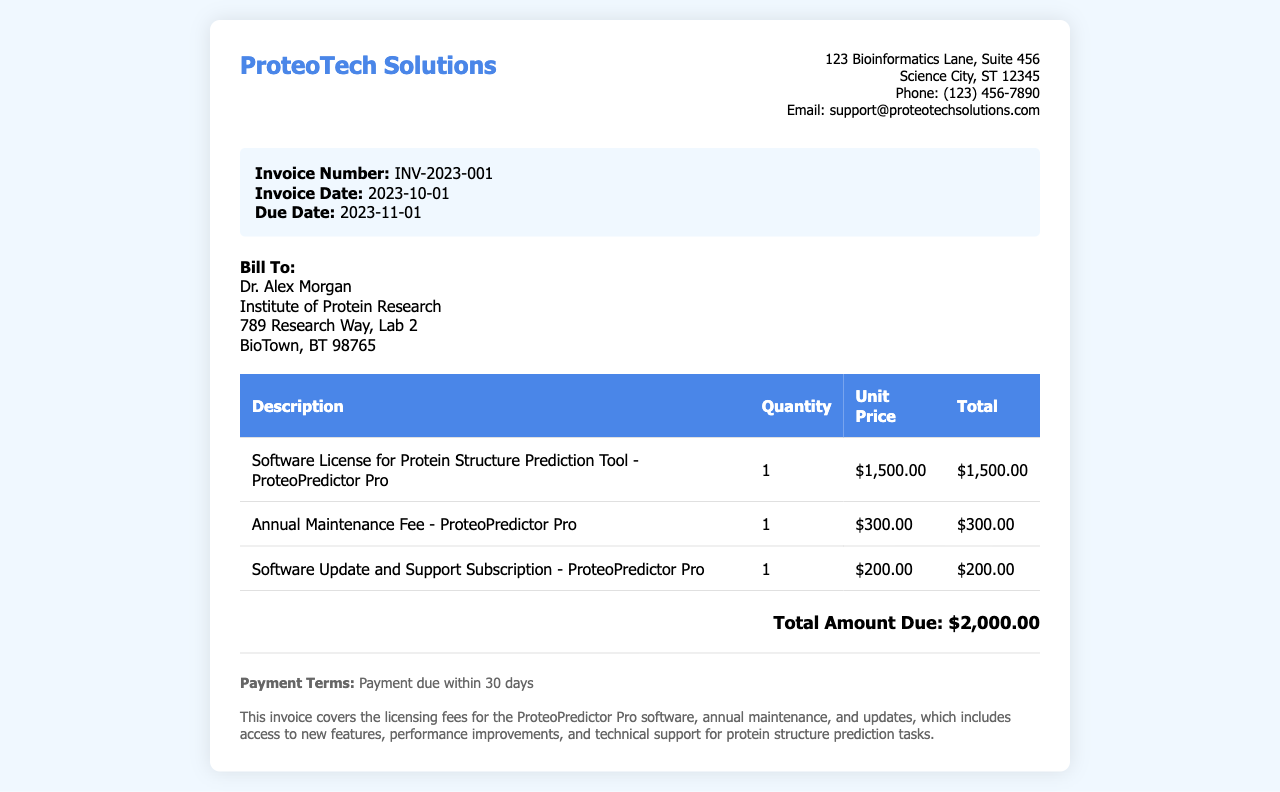What is the invoice number? The invoice number is stated in the document as INV-2023-001.
Answer: INV-2023-001 Who is the billing contact? The billing contact listed in the document is Dr. Alex Morgan.
Answer: Dr. Alex Morgan What is the total amount due? The total amount due is summed up from the total of line items in the invoice, which is $2,000.00.
Answer: $2,000.00 What is the due date for payment? The due date for payment is specified in the document as November 1, 2023.
Answer: 2023-11-01 How much is the annual maintenance fee? The invoice lists the annual maintenance fee for ProteoPredictor Pro as $300.00.
Answer: $300.00 What type of software is covered by this invoice? The invoice covers the licensing fee for the software ProteoPredictor Pro.
Answer: ProteoPredictor Pro How long is the software update and support subscription valid for? The document does not specify a duration for the subscription, but typically it covers one year.
Answer: One year What is included in the software update and support? The document mentions access to new features, performance improvements, and technical support.
Answer: New features, performance improvements, and technical support 